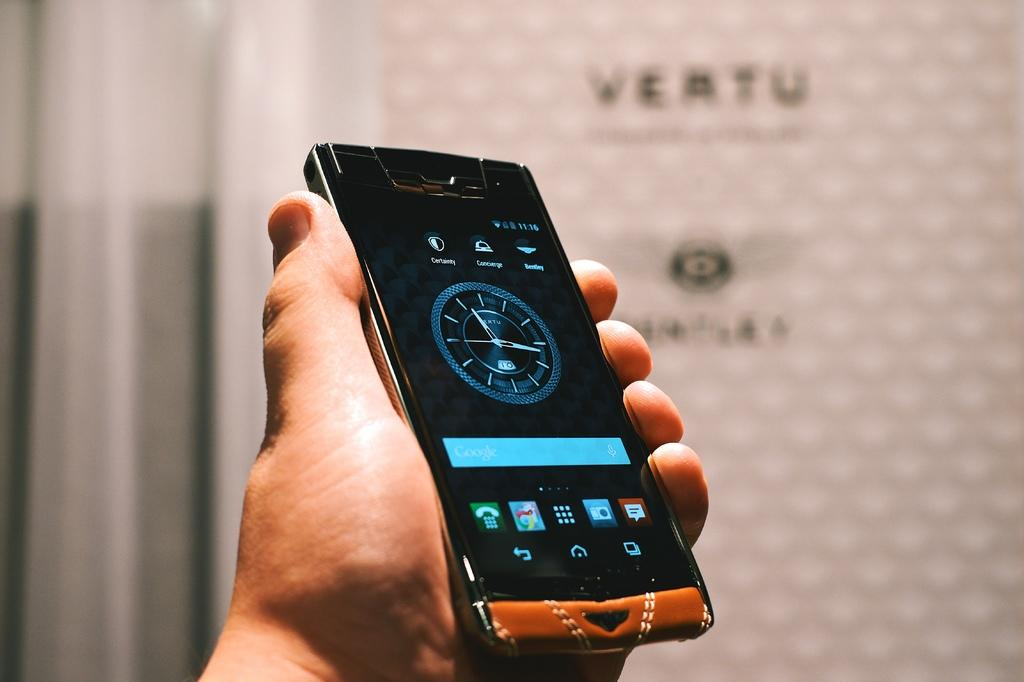<image>
Summarize the visual content of the image. A phone shows a clock by VERTU in the center of the screen 